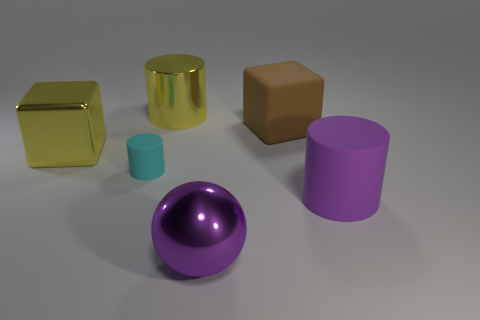Are there any large yellow metallic things of the same shape as the brown object?
Keep it short and to the point. Yes. Does the shiny sphere have the same color as the small object?
Make the answer very short. No. There is a matte cylinder on the left side of the big rubber cylinder; are there any big objects left of it?
Make the answer very short. Yes. There is a rubber cylinder left of the big purple object that is in front of the big cylinder in front of the big yellow block; what is its size?
Make the answer very short. Small. There is a yellow block that is the same size as the brown matte object; what is its material?
Provide a short and direct response. Metal. Do the matte cylinder behind the purple cylinder and the brown thing have the same size?
Offer a terse response. No. There is a object that is both in front of the cyan rubber cylinder and on the left side of the purple matte cylinder; what shape is it?
Offer a terse response. Sphere. What size is the other cylinder that is made of the same material as the large purple cylinder?
Make the answer very short. Small. There is a matte cylinder behind the large purple cylinder; is its color the same as the matte block?
Make the answer very short. No. Is the number of tiny objects that are right of the purple metallic object the same as the number of small rubber objects behind the metal cube?
Ensure brevity in your answer.  Yes. 